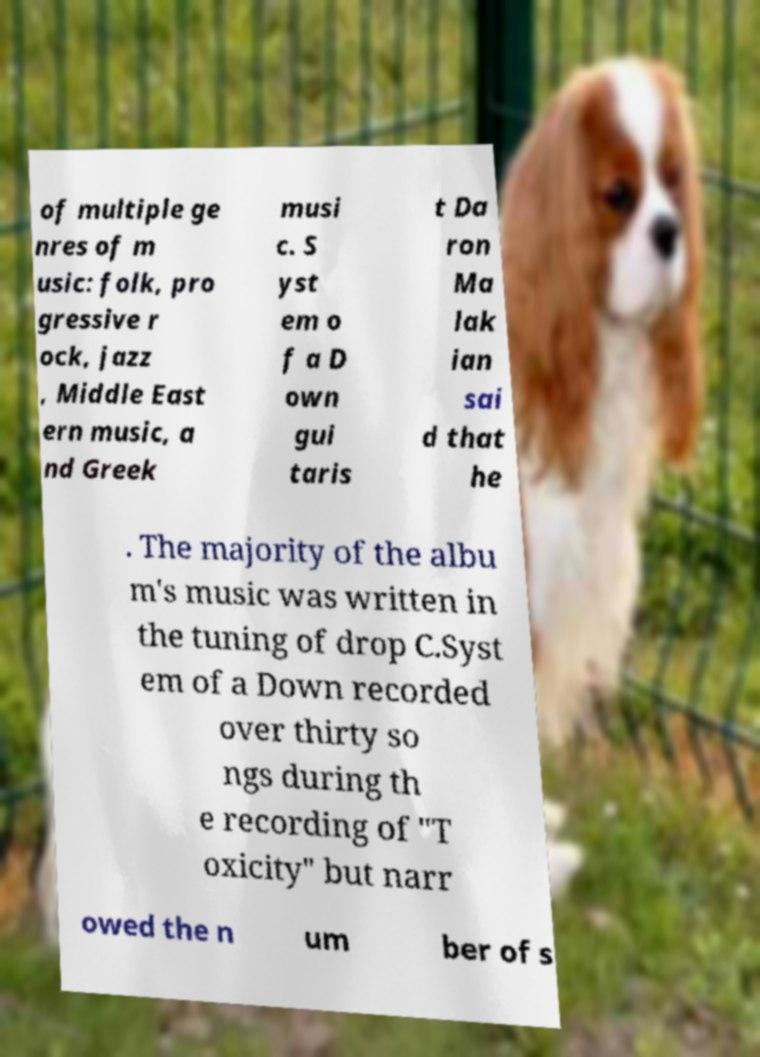For documentation purposes, I need the text within this image transcribed. Could you provide that? of multiple ge nres of m usic: folk, pro gressive r ock, jazz , Middle East ern music, a nd Greek musi c. S yst em o f a D own gui taris t Da ron Ma lak ian sai d that he . The majority of the albu m's music was written in the tuning of drop C.Syst em of a Down recorded over thirty so ngs during th e recording of "T oxicity" but narr owed the n um ber of s 